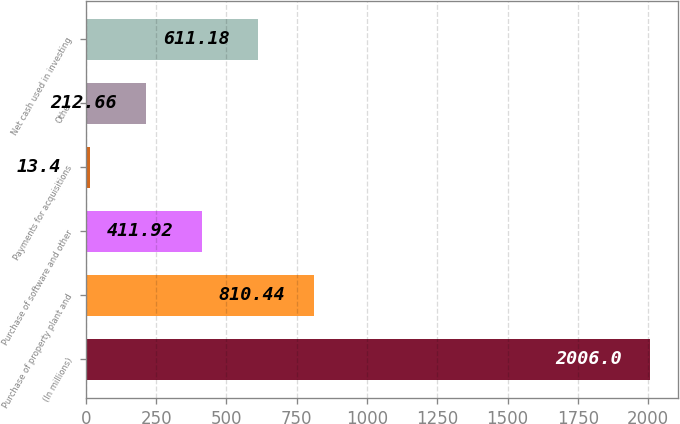Convert chart. <chart><loc_0><loc_0><loc_500><loc_500><bar_chart><fcel>(In millions)<fcel>Purchase of property plant and<fcel>Purchase of software and other<fcel>Payments for acquisitions<fcel>Other<fcel>Net cash used in investing<nl><fcel>2006<fcel>810.44<fcel>411.92<fcel>13.4<fcel>212.66<fcel>611.18<nl></chart> 